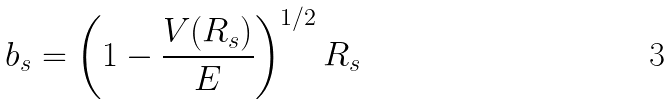Convert formula to latex. <formula><loc_0><loc_0><loc_500><loc_500>b _ { s } = \left ( 1 - \frac { V ( R _ { s } ) } { E } \right ) ^ { 1 / 2 } R _ { s }</formula> 